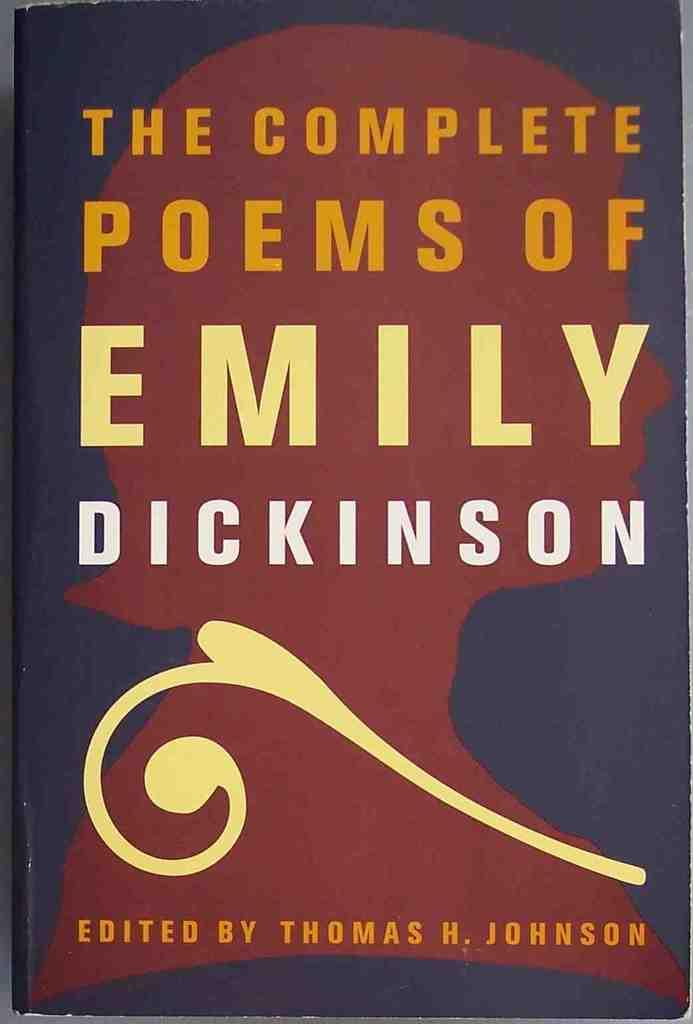<image>
Render a clear and concise summary of the photo. A book of Emily Dickinson's poetry sits on a table. 